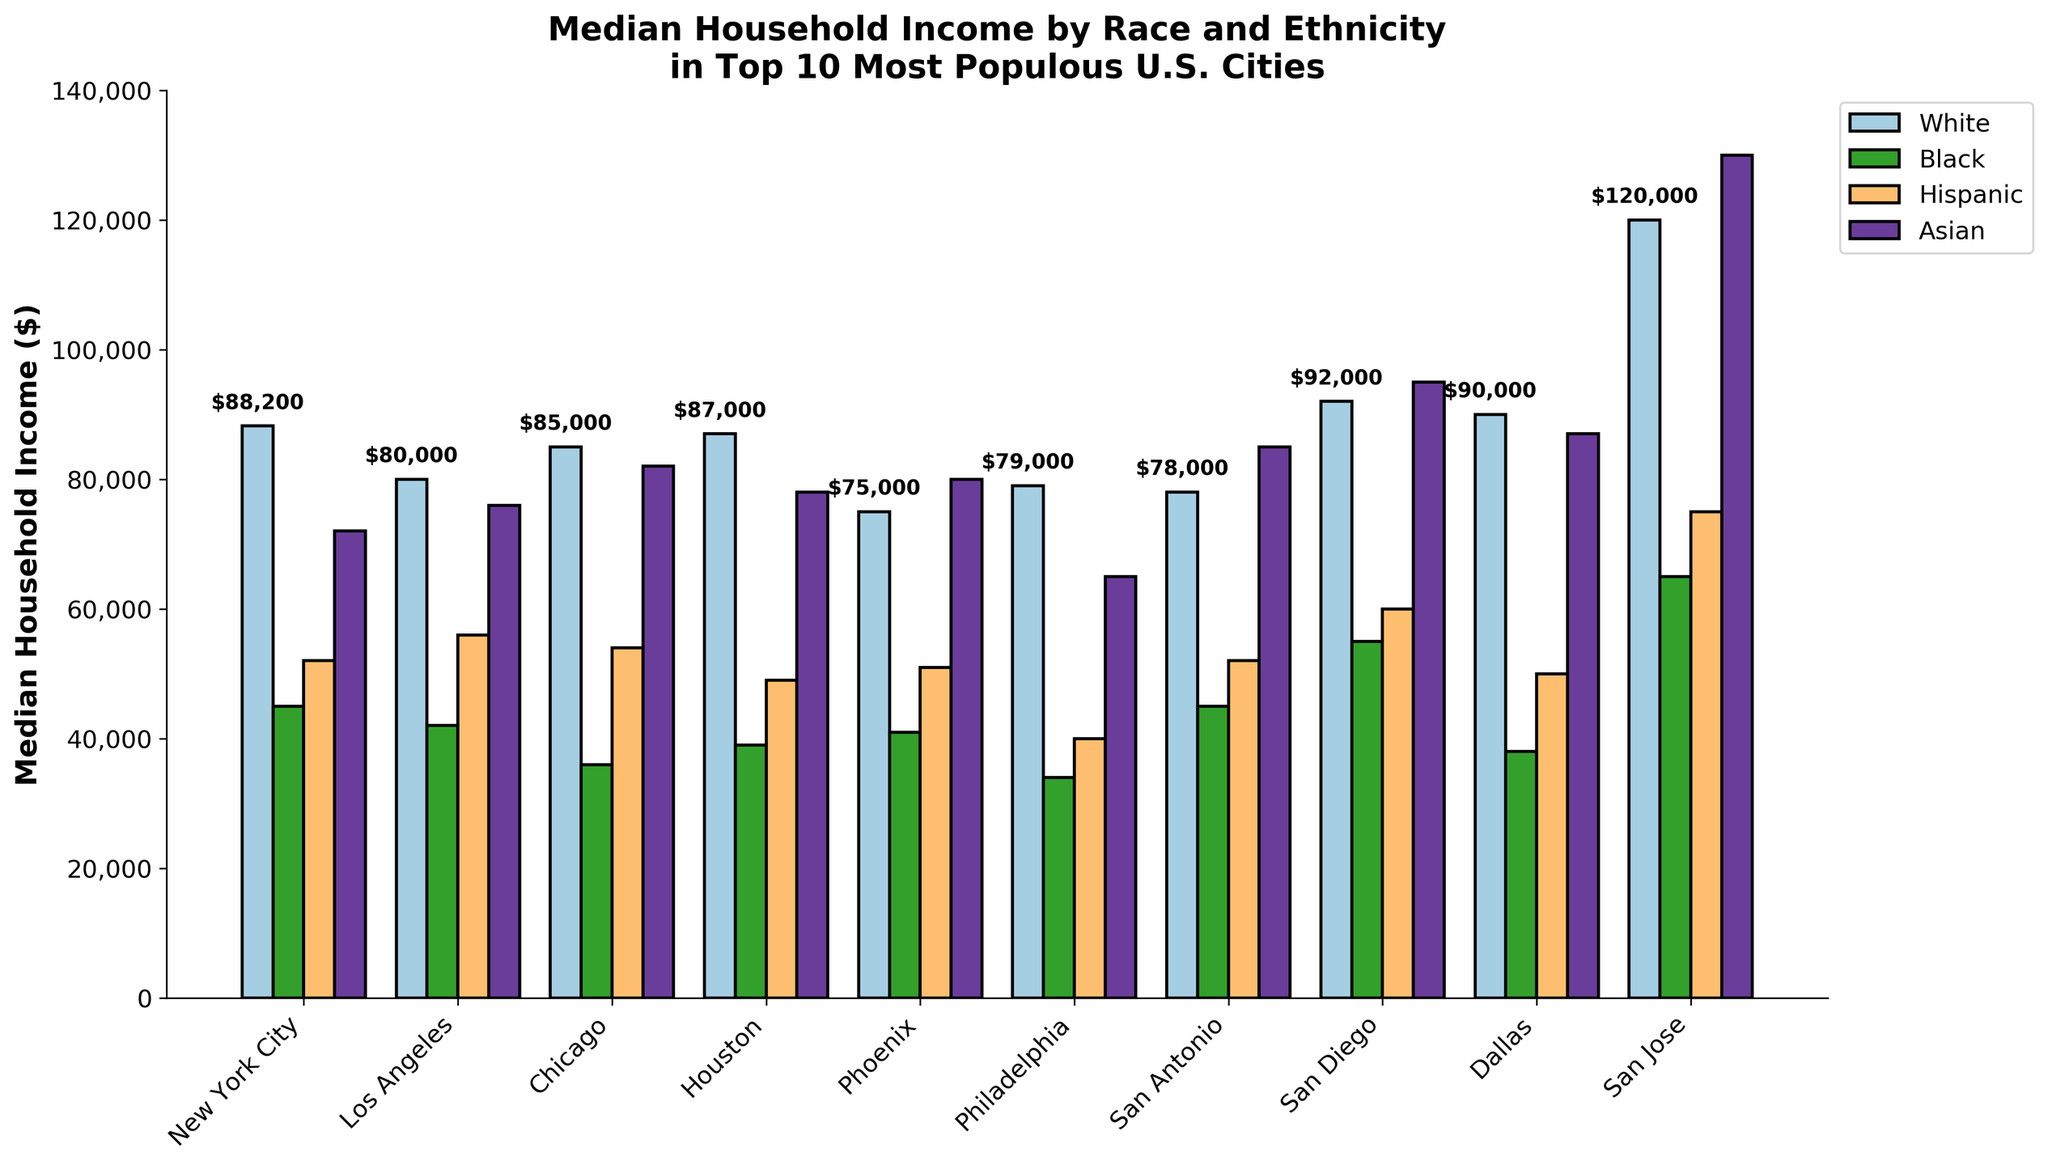Which city has the highest median household income among the White population? Observe the height of the bars representing the White population across all cities; the tallest bar indicates the highest median household income. San Jose has the tallest bar for the White population.
Answer: San Jose Which racial group has the lowest median household income in Philadelphia? Compare the heights of the bars in Philadelphia; the shortest bar corresponds to the lowest median household income. The Black population bar is the shortest in Philadelphia.
Answer: Black What is the difference in median household income between the Asian and Hispanic populations in San Diego? Locate the bars for the Asian and Hispanic populations in San Diego and subtract the height of the Hispanic bar from the height of the Asian bar. Median household income for Asian is $95,000 and for Hispanic is $60,000 in San Diego. So, the difference is $95,000 - $60,000 = $35,000.
Answer: $35,000 Which city has the smallest disparity between White and Black median household incomes? For each city, calculate the difference between the heights of the White and Black bars, and find the smallest value. Philadelphia has the smallest disparity, with the difference being $79,000 (White) - $34,000 (Black) = $45,000.
Answer: Philadelphia How does the median household income of the Hispanic population in Los Angeles compare to that in Houston? Compare the heights of the Hispanic population bars between Los Angeles and Houston. The bar in Los Angeles is higher at $56,000 compared to Houston at $49,000.
Answer: Higher in Los Angeles What is the average median household income of the Asian population in the top 10 cities? Sum the heights of the bars for the Asian population across all cities and divide by the number of cities. The values are $72,000, $76,000, $82,000, $78,000, $80,000, $65,000, $85,000, $95,000, $87,000, $130,000. The sum is $850,000. So, the average is $850,000 / 10 = $85,000.
Answer: $85,000 Which racial group generally has the highest, and which has the lowest median household income across most cities? Observe the pattern in the heights of bars across cities for each racial group. Generally, the White population has the highest median household income, while the Black population has the lowest.
Answer: Highest: White, Lowest: Black In which city is the median household income for the Black population highest? Identify the tallest bar for the Black population across all cities. San Jose's bar for the Black population is the tallest at $65,000.
Answer: San Jose What is the median household income of the Hispanic population in Chicago? Look at the height of the bar representing the Hispanic population in Chicago. The median household income is $54,000.
Answer: $54,000 